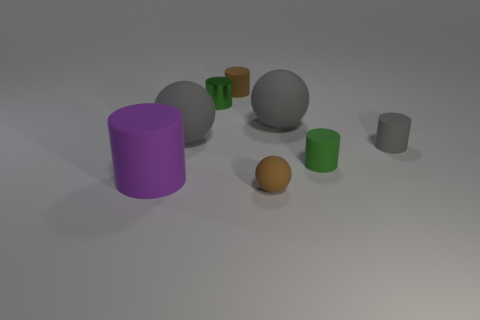Is there any other thing that is the same color as the big matte cylinder?
Keep it short and to the point. No. Is the color of the small thing that is on the left side of the small brown cylinder the same as the ball on the left side of the metal cylinder?
Your answer should be very brief. No. Is the number of tiny rubber balls in front of the gray matte cylinder greater than the number of tiny brown matte cylinders left of the purple cylinder?
Your answer should be very brief. Yes. What is the material of the small gray cylinder?
Your response must be concise. Rubber. The thing that is behind the green object that is on the left side of the small rubber cylinder that is left of the green matte thing is what shape?
Make the answer very short. Cylinder. What number of other objects are there of the same material as the purple thing?
Your response must be concise. 6. Do the green thing behind the small green rubber thing and the brown thing that is in front of the large purple rubber object have the same material?
Your answer should be very brief. No. What number of objects are to the right of the purple matte cylinder and left of the shiny object?
Keep it short and to the point. 1. Are there any other big things of the same shape as the large purple object?
Ensure brevity in your answer.  No. There is a gray object that is the same size as the brown cylinder; what is its shape?
Provide a succinct answer. Cylinder. 